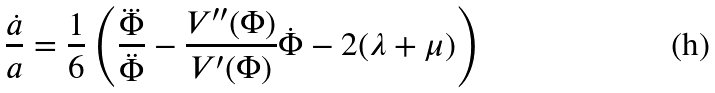<formula> <loc_0><loc_0><loc_500><loc_500>\frac { \dot { a } } { a } = \frac { 1 } { 6 } \left ( \frac { \dddot { \Phi } } { \ddot { \Phi } } - \frac { V ^ { \prime \prime } ( \Phi ) } { V ^ { \prime } ( \Phi ) } \dot { \Phi } - 2 ( \lambda + \mu ) \right )</formula> 